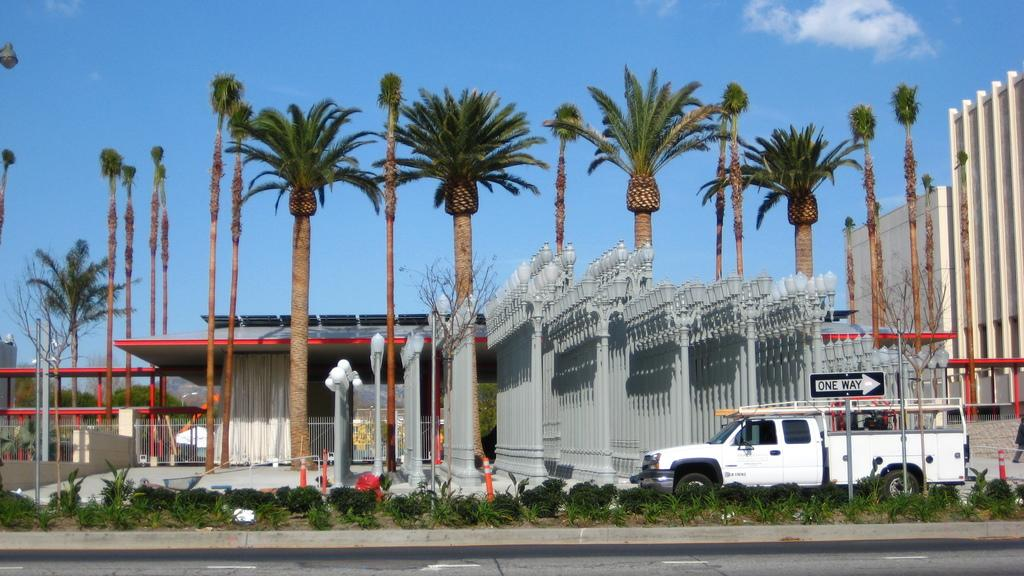What is visible in the center of the image? The sky is visible in the center of the image. What can be seen in the sky? Clouds are present in the image. What type of structures are in the image? There are buildings in the image. What type of vegetation is present in the image? Trees and plants are present in the image. What type of street furniture can be seen in the image? Light poles of different sizes are visible in the image. What mode of transportation is present in the image? There is at least one vehicle in the image. What other objects can be seen in the image? There are a few other objects in the image. What type of skin condition is visible on the trees in the image? There is no mention of any skin condition on the trees in the image. The trees appear to be healthy and green. 